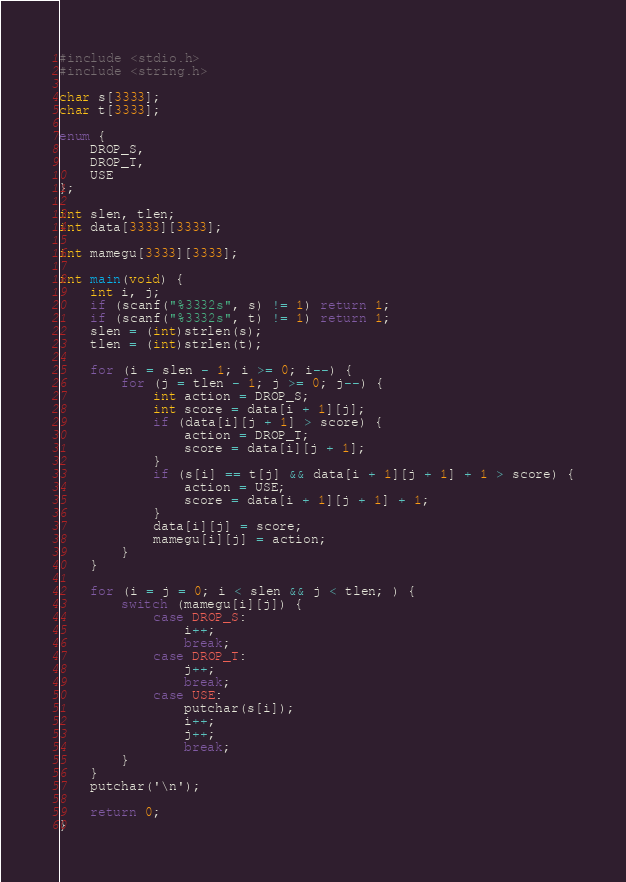<code> <loc_0><loc_0><loc_500><loc_500><_C_>#include <stdio.h>
#include <string.h>

char s[3333];
char t[3333];

enum {
	DROP_S,
	DROP_T,
	USE
};

int slen, tlen;
int data[3333][3333];

int mamegu[3333][3333];

int main(void) {
	int i, j;
	if (scanf("%3332s", s) != 1) return 1;
	if (scanf("%3332s", t) != 1) return 1;
	slen = (int)strlen(s);
	tlen = (int)strlen(t);

	for (i = slen - 1; i >= 0; i--) {
		for (j = tlen - 1; j >= 0; j--) {
			int action = DROP_S;
			int score = data[i + 1][j];
			if (data[i][j + 1] > score) {
				action = DROP_T;
				score = data[i][j + 1];
			}
			if (s[i] == t[j] && data[i + 1][j + 1] + 1 > score) {
				action = USE;
				score = data[i + 1][j + 1] + 1;
			}
			data[i][j] = score;
			mamegu[i][j] = action;
		}
	}

	for (i = j = 0; i < slen && j < tlen; ) {
		switch (mamegu[i][j]) {
			case DROP_S:
				i++;
				break;
			case DROP_T:
				j++;
				break;
			case USE:
				putchar(s[i]);
				i++;
				j++;
				break;
		}
	}
	putchar('\n');

	return 0;
}
</code> 